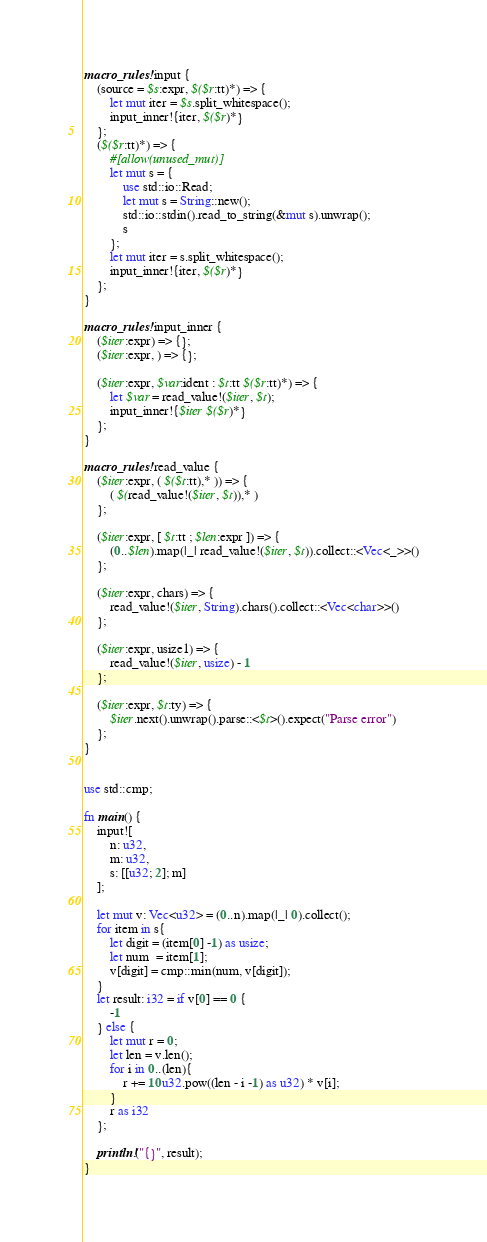Convert code to text. <code><loc_0><loc_0><loc_500><loc_500><_Rust_>macro_rules! input {
    (source = $s:expr, $($r:tt)*) => {
        let mut iter = $s.split_whitespace();
        input_inner!{iter, $($r)*}
    };
    ($($r:tt)*) => {
        #[allow(unused_mut)]
        let mut s = {
            use std::io::Read;
            let mut s = String::new();
            std::io::stdin().read_to_string(&mut s).unwrap();
            s
        };
        let mut iter = s.split_whitespace();
        input_inner!{iter, $($r)*}
    };
}

macro_rules! input_inner {
    ($iter:expr) => {};
    ($iter:expr, ) => {};

    ($iter:expr, $var:ident : $t:tt $($r:tt)*) => {
        let $var = read_value!($iter, $t);
        input_inner!{$iter $($r)*}
    };
}

macro_rules! read_value {
    ($iter:expr, ( $($t:tt),* )) => {
        ( $(read_value!($iter, $t)),* )
    };

    ($iter:expr, [ $t:tt ; $len:expr ]) => {
        (0..$len).map(|_| read_value!($iter, $t)).collect::<Vec<_>>()
    };

    ($iter:expr, chars) => {
        read_value!($iter, String).chars().collect::<Vec<char>>()
    };

    ($iter:expr, usize1) => {
        read_value!($iter, usize) - 1
    };

    ($iter:expr, $t:ty) => {
        $iter.next().unwrap().parse::<$t>().expect("Parse error")
    };
}


use std::cmp;

fn main() {
    input![
        n: u32,
        m: u32,
        s: [[u32; 2]; m]
    ];

    let mut v: Vec<u32> = (0..n).map(|_| 0).collect();
    for item in s{
        let digit = (item[0] -1) as usize;
        let num  = item[1];
        v[digit] = cmp::min(num, v[digit]);
    }
    let result: i32 = if v[0] == 0 {
        -1
    } else {
        let mut r = 0;
        let len = v.len();
        for i in 0..(len){
            r += 10u32.pow((len - i -1) as u32) * v[i];
        }
        r as i32
    };

    println!("{}", result);
}
</code> 